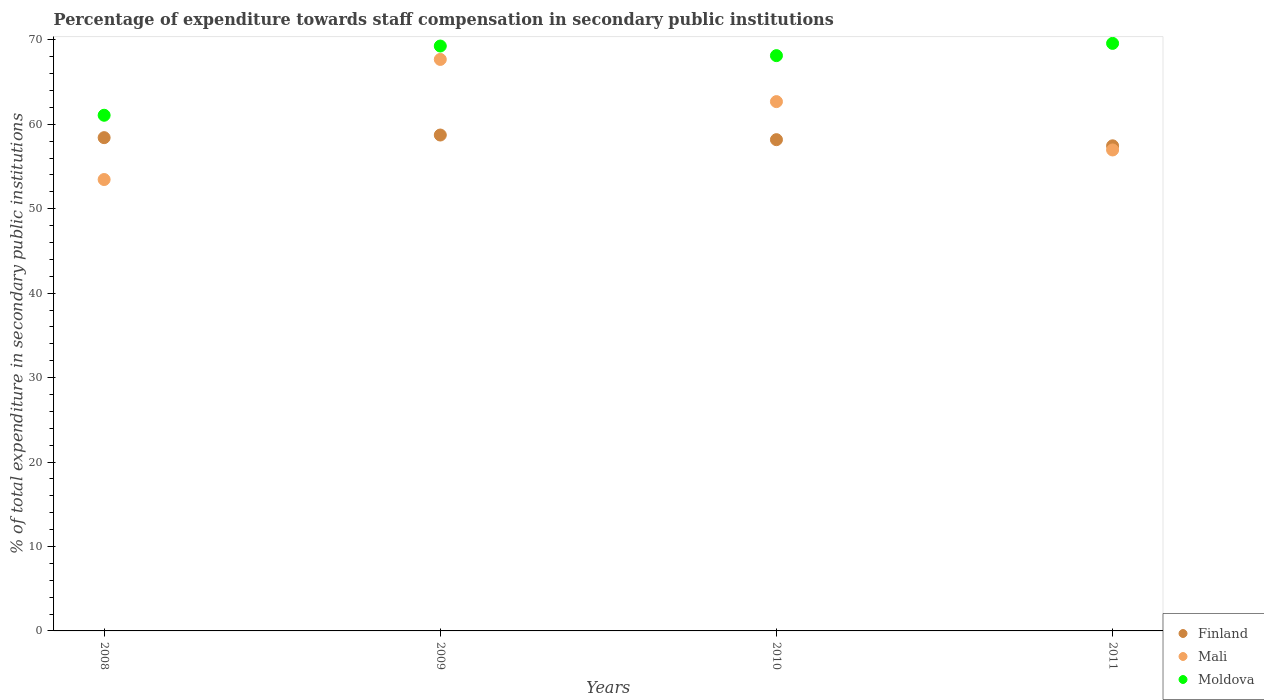What is the percentage of expenditure towards staff compensation in Mali in 2009?
Provide a short and direct response. 67.68. Across all years, what is the maximum percentage of expenditure towards staff compensation in Finland?
Your answer should be compact. 58.73. Across all years, what is the minimum percentage of expenditure towards staff compensation in Moldova?
Offer a very short reply. 61.07. In which year was the percentage of expenditure towards staff compensation in Finland maximum?
Ensure brevity in your answer.  2009. In which year was the percentage of expenditure towards staff compensation in Finland minimum?
Give a very brief answer. 2011. What is the total percentage of expenditure towards staff compensation in Mali in the graph?
Offer a terse response. 240.78. What is the difference between the percentage of expenditure towards staff compensation in Finland in 2008 and that in 2010?
Ensure brevity in your answer.  0.24. What is the difference between the percentage of expenditure towards staff compensation in Finland in 2009 and the percentage of expenditure towards staff compensation in Moldova in 2008?
Offer a very short reply. -2.34. What is the average percentage of expenditure towards staff compensation in Mali per year?
Give a very brief answer. 60.19. In the year 2010, what is the difference between the percentage of expenditure towards staff compensation in Finland and percentage of expenditure towards staff compensation in Moldova?
Keep it short and to the point. -9.95. In how many years, is the percentage of expenditure towards staff compensation in Finland greater than 28 %?
Your answer should be compact. 4. What is the ratio of the percentage of expenditure towards staff compensation in Mali in 2008 to that in 2009?
Your answer should be compact. 0.79. Is the percentage of expenditure towards staff compensation in Moldova in 2008 less than that in 2011?
Keep it short and to the point. Yes. Is the difference between the percentage of expenditure towards staff compensation in Finland in 2008 and 2010 greater than the difference between the percentage of expenditure towards staff compensation in Moldova in 2008 and 2010?
Give a very brief answer. Yes. What is the difference between the highest and the second highest percentage of expenditure towards staff compensation in Moldova?
Your answer should be compact. 0.31. What is the difference between the highest and the lowest percentage of expenditure towards staff compensation in Mali?
Your answer should be compact. 14.22. Is the sum of the percentage of expenditure towards staff compensation in Mali in 2010 and 2011 greater than the maximum percentage of expenditure towards staff compensation in Finland across all years?
Your answer should be compact. Yes. Is it the case that in every year, the sum of the percentage of expenditure towards staff compensation in Mali and percentage of expenditure towards staff compensation in Moldova  is greater than the percentage of expenditure towards staff compensation in Finland?
Offer a very short reply. Yes. Does the percentage of expenditure towards staff compensation in Moldova monotonically increase over the years?
Give a very brief answer. No. Is the percentage of expenditure towards staff compensation in Mali strictly less than the percentage of expenditure towards staff compensation in Moldova over the years?
Provide a succinct answer. Yes. How many dotlines are there?
Offer a very short reply. 3. What is the difference between two consecutive major ticks on the Y-axis?
Your answer should be compact. 10. Does the graph contain any zero values?
Your answer should be compact. No. Does the graph contain grids?
Your answer should be very brief. No. How many legend labels are there?
Provide a short and direct response. 3. How are the legend labels stacked?
Make the answer very short. Vertical. What is the title of the graph?
Make the answer very short. Percentage of expenditure towards staff compensation in secondary public institutions. Does "Eritrea" appear as one of the legend labels in the graph?
Your answer should be very brief. No. What is the label or title of the Y-axis?
Your answer should be compact. % of total expenditure in secondary public institutions. What is the % of total expenditure in secondary public institutions in Finland in 2008?
Offer a terse response. 58.42. What is the % of total expenditure in secondary public institutions in Mali in 2008?
Your response must be concise. 53.46. What is the % of total expenditure in secondary public institutions in Moldova in 2008?
Give a very brief answer. 61.07. What is the % of total expenditure in secondary public institutions in Finland in 2009?
Provide a succinct answer. 58.73. What is the % of total expenditure in secondary public institutions of Mali in 2009?
Provide a short and direct response. 67.68. What is the % of total expenditure in secondary public institutions of Moldova in 2009?
Keep it short and to the point. 69.27. What is the % of total expenditure in secondary public institutions of Finland in 2010?
Provide a succinct answer. 58.18. What is the % of total expenditure in secondary public institutions in Mali in 2010?
Your response must be concise. 62.68. What is the % of total expenditure in secondary public institutions in Moldova in 2010?
Offer a terse response. 68.13. What is the % of total expenditure in secondary public institutions in Finland in 2011?
Provide a succinct answer. 57.45. What is the % of total expenditure in secondary public institutions of Mali in 2011?
Give a very brief answer. 56.96. What is the % of total expenditure in secondary public institutions of Moldova in 2011?
Make the answer very short. 69.58. Across all years, what is the maximum % of total expenditure in secondary public institutions in Finland?
Your response must be concise. 58.73. Across all years, what is the maximum % of total expenditure in secondary public institutions in Mali?
Give a very brief answer. 67.68. Across all years, what is the maximum % of total expenditure in secondary public institutions in Moldova?
Give a very brief answer. 69.58. Across all years, what is the minimum % of total expenditure in secondary public institutions of Finland?
Provide a succinct answer. 57.45. Across all years, what is the minimum % of total expenditure in secondary public institutions in Mali?
Keep it short and to the point. 53.46. Across all years, what is the minimum % of total expenditure in secondary public institutions of Moldova?
Give a very brief answer. 61.07. What is the total % of total expenditure in secondary public institutions of Finland in the graph?
Your answer should be very brief. 232.77. What is the total % of total expenditure in secondary public institutions of Mali in the graph?
Provide a succinct answer. 240.78. What is the total % of total expenditure in secondary public institutions of Moldova in the graph?
Provide a succinct answer. 268.04. What is the difference between the % of total expenditure in secondary public institutions of Finland in 2008 and that in 2009?
Give a very brief answer. -0.31. What is the difference between the % of total expenditure in secondary public institutions of Mali in 2008 and that in 2009?
Offer a terse response. -14.22. What is the difference between the % of total expenditure in secondary public institutions of Moldova in 2008 and that in 2009?
Provide a succinct answer. -8.2. What is the difference between the % of total expenditure in secondary public institutions of Finland in 2008 and that in 2010?
Provide a short and direct response. 0.24. What is the difference between the % of total expenditure in secondary public institutions of Mali in 2008 and that in 2010?
Keep it short and to the point. -9.23. What is the difference between the % of total expenditure in secondary public institutions of Moldova in 2008 and that in 2010?
Offer a terse response. -7.06. What is the difference between the % of total expenditure in secondary public institutions of Finland in 2008 and that in 2011?
Ensure brevity in your answer.  0.97. What is the difference between the % of total expenditure in secondary public institutions of Mali in 2008 and that in 2011?
Give a very brief answer. -3.5. What is the difference between the % of total expenditure in secondary public institutions in Moldova in 2008 and that in 2011?
Provide a short and direct response. -8.51. What is the difference between the % of total expenditure in secondary public institutions of Finland in 2009 and that in 2010?
Provide a succinct answer. 0.55. What is the difference between the % of total expenditure in secondary public institutions of Mali in 2009 and that in 2010?
Make the answer very short. 5. What is the difference between the % of total expenditure in secondary public institutions of Moldova in 2009 and that in 2010?
Keep it short and to the point. 1.14. What is the difference between the % of total expenditure in secondary public institutions in Finland in 2009 and that in 2011?
Offer a terse response. 1.28. What is the difference between the % of total expenditure in secondary public institutions in Mali in 2009 and that in 2011?
Ensure brevity in your answer.  10.72. What is the difference between the % of total expenditure in secondary public institutions in Moldova in 2009 and that in 2011?
Offer a very short reply. -0.31. What is the difference between the % of total expenditure in secondary public institutions in Finland in 2010 and that in 2011?
Keep it short and to the point. 0.73. What is the difference between the % of total expenditure in secondary public institutions in Mali in 2010 and that in 2011?
Your answer should be compact. 5.73. What is the difference between the % of total expenditure in secondary public institutions in Moldova in 2010 and that in 2011?
Offer a very short reply. -1.45. What is the difference between the % of total expenditure in secondary public institutions in Finland in 2008 and the % of total expenditure in secondary public institutions in Mali in 2009?
Ensure brevity in your answer.  -9.26. What is the difference between the % of total expenditure in secondary public institutions in Finland in 2008 and the % of total expenditure in secondary public institutions in Moldova in 2009?
Your answer should be very brief. -10.85. What is the difference between the % of total expenditure in secondary public institutions in Mali in 2008 and the % of total expenditure in secondary public institutions in Moldova in 2009?
Your answer should be very brief. -15.81. What is the difference between the % of total expenditure in secondary public institutions of Finland in 2008 and the % of total expenditure in secondary public institutions of Mali in 2010?
Your response must be concise. -4.27. What is the difference between the % of total expenditure in secondary public institutions of Finland in 2008 and the % of total expenditure in secondary public institutions of Moldova in 2010?
Provide a succinct answer. -9.71. What is the difference between the % of total expenditure in secondary public institutions in Mali in 2008 and the % of total expenditure in secondary public institutions in Moldova in 2010?
Give a very brief answer. -14.67. What is the difference between the % of total expenditure in secondary public institutions in Finland in 2008 and the % of total expenditure in secondary public institutions in Mali in 2011?
Your answer should be very brief. 1.46. What is the difference between the % of total expenditure in secondary public institutions of Finland in 2008 and the % of total expenditure in secondary public institutions of Moldova in 2011?
Provide a short and direct response. -11.16. What is the difference between the % of total expenditure in secondary public institutions in Mali in 2008 and the % of total expenditure in secondary public institutions in Moldova in 2011?
Your answer should be compact. -16.12. What is the difference between the % of total expenditure in secondary public institutions of Finland in 2009 and the % of total expenditure in secondary public institutions of Mali in 2010?
Give a very brief answer. -3.96. What is the difference between the % of total expenditure in secondary public institutions of Finland in 2009 and the % of total expenditure in secondary public institutions of Moldova in 2010?
Your answer should be compact. -9.4. What is the difference between the % of total expenditure in secondary public institutions of Mali in 2009 and the % of total expenditure in secondary public institutions of Moldova in 2010?
Keep it short and to the point. -0.45. What is the difference between the % of total expenditure in secondary public institutions in Finland in 2009 and the % of total expenditure in secondary public institutions in Mali in 2011?
Offer a terse response. 1.77. What is the difference between the % of total expenditure in secondary public institutions of Finland in 2009 and the % of total expenditure in secondary public institutions of Moldova in 2011?
Provide a succinct answer. -10.85. What is the difference between the % of total expenditure in secondary public institutions in Mali in 2009 and the % of total expenditure in secondary public institutions in Moldova in 2011?
Provide a short and direct response. -1.9. What is the difference between the % of total expenditure in secondary public institutions of Finland in 2010 and the % of total expenditure in secondary public institutions of Mali in 2011?
Provide a succinct answer. 1.22. What is the difference between the % of total expenditure in secondary public institutions in Finland in 2010 and the % of total expenditure in secondary public institutions in Moldova in 2011?
Keep it short and to the point. -11.4. What is the difference between the % of total expenditure in secondary public institutions of Mali in 2010 and the % of total expenditure in secondary public institutions of Moldova in 2011?
Offer a very short reply. -6.9. What is the average % of total expenditure in secondary public institutions in Finland per year?
Give a very brief answer. 58.19. What is the average % of total expenditure in secondary public institutions of Mali per year?
Provide a succinct answer. 60.19. What is the average % of total expenditure in secondary public institutions of Moldova per year?
Your response must be concise. 67.01. In the year 2008, what is the difference between the % of total expenditure in secondary public institutions of Finland and % of total expenditure in secondary public institutions of Mali?
Make the answer very short. 4.96. In the year 2008, what is the difference between the % of total expenditure in secondary public institutions in Finland and % of total expenditure in secondary public institutions in Moldova?
Your answer should be very brief. -2.65. In the year 2008, what is the difference between the % of total expenditure in secondary public institutions of Mali and % of total expenditure in secondary public institutions of Moldova?
Give a very brief answer. -7.61. In the year 2009, what is the difference between the % of total expenditure in secondary public institutions in Finland and % of total expenditure in secondary public institutions in Mali?
Give a very brief answer. -8.95. In the year 2009, what is the difference between the % of total expenditure in secondary public institutions of Finland and % of total expenditure in secondary public institutions of Moldova?
Offer a terse response. -10.54. In the year 2009, what is the difference between the % of total expenditure in secondary public institutions in Mali and % of total expenditure in secondary public institutions in Moldova?
Give a very brief answer. -1.59. In the year 2010, what is the difference between the % of total expenditure in secondary public institutions in Finland and % of total expenditure in secondary public institutions in Mali?
Keep it short and to the point. -4.51. In the year 2010, what is the difference between the % of total expenditure in secondary public institutions in Finland and % of total expenditure in secondary public institutions in Moldova?
Give a very brief answer. -9.95. In the year 2010, what is the difference between the % of total expenditure in secondary public institutions in Mali and % of total expenditure in secondary public institutions in Moldova?
Ensure brevity in your answer.  -5.45. In the year 2011, what is the difference between the % of total expenditure in secondary public institutions in Finland and % of total expenditure in secondary public institutions in Mali?
Keep it short and to the point. 0.49. In the year 2011, what is the difference between the % of total expenditure in secondary public institutions in Finland and % of total expenditure in secondary public institutions in Moldova?
Your answer should be compact. -12.13. In the year 2011, what is the difference between the % of total expenditure in secondary public institutions in Mali and % of total expenditure in secondary public institutions in Moldova?
Provide a short and direct response. -12.62. What is the ratio of the % of total expenditure in secondary public institutions of Finland in 2008 to that in 2009?
Provide a short and direct response. 0.99. What is the ratio of the % of total expenditure in secondary public institutions in Mali in 2008 to that in 2009?
Keep it short and to the point. 0.79. What is the ratio of the % of total expenditure in secondary public institutions in Moldova in 2008 to that in 2009?
Make the answer very short. 0.88. What is the ratio of the % of total expenditure in secondary public institutions of Mali in 2008 to that in 2010?
Your response must be concise. 0.85. What is the ratio of the % of total expenditure in secondary public institutions in Moldova in 2008 to that in 2010?
Keep it short and to the point. 0.9. What is the ratio of the % of total expenditure in secondary public institutions of Finland in 2008 to that in 2011?
Give a very brief answer. 1.02. What is the ratio of the % of total expenditure in secondary public institutions in Mali in 2008 to that in 2011?
Give a very brief answer. 0.94. What is the ratio of the % of total expenditure in secondary public institutions in Moldova in 2008 to that in 2011?
Keep it short and to the point. 0.88. What is the ratio of the % of total expenditure in secondary public institutions in Finland in 2009 to that in 2010?
Keep it short and to the point. 1.01. What is the ratio of the % of total expenditure in secondary public institutions in Mali in 2009 to that in 2010?
Make the answer very short. 1.08. What is the ratio of the % of total expenditure in secondary public institutions of Moldova in 2009 to that in 2010?
Ensure brevity in your answer.  1.02. What is the ratio of the % of total expenditure in secondary public institutions of Finland in 2009 to that in 2011?
Offer a terse response. 1.02. What is the ratio of the % of total expenditure in secondary public institutions in Mali in 2009 to that in 2011?
Keep it short and to the point. 1.19. What is the ratio of the % of total expenditure in secondary public institutions in Finland in 2010 to that in 2011?
Give a very brief answer. 1.01. What is the ratio of the % of total expenditure in secondary public institutions in Mali in 2010 to that in 2011?
Your response must be concise. 1.1. What is the ratio of the % of total expenditure in secondary public institutions in Moldova in 2010 to that in 2011?
Your answer should be compact. 0.98. What is the difference between the highest and the second highest % of total expenditure in secondary public institutions in Finland?
Ensure brevity in your answer.  0.31. What is the difference between the highest and the second highest % of total expenditure in secondary public institutions of Mali?
Keep it short and to the point. 5. What is the difference between the highest and the second highest % of total expenditure in secondary public institutions of Moldova?
Keep it short and to the point. 0.31. What is the difference between the highest and the lowest % of total expenditure in secondary public institutions of Finland?
Offer a terse response. 1.28. What is the difference between the highest and the lowest % of total expenditure in secondary public institutions in Mali?
Your answer should be compact. 14.22. What is the difference between the highest and the lowest % of total expenditure in secondary public institutions of Moldova?
Offer a terse response. 8.51. 